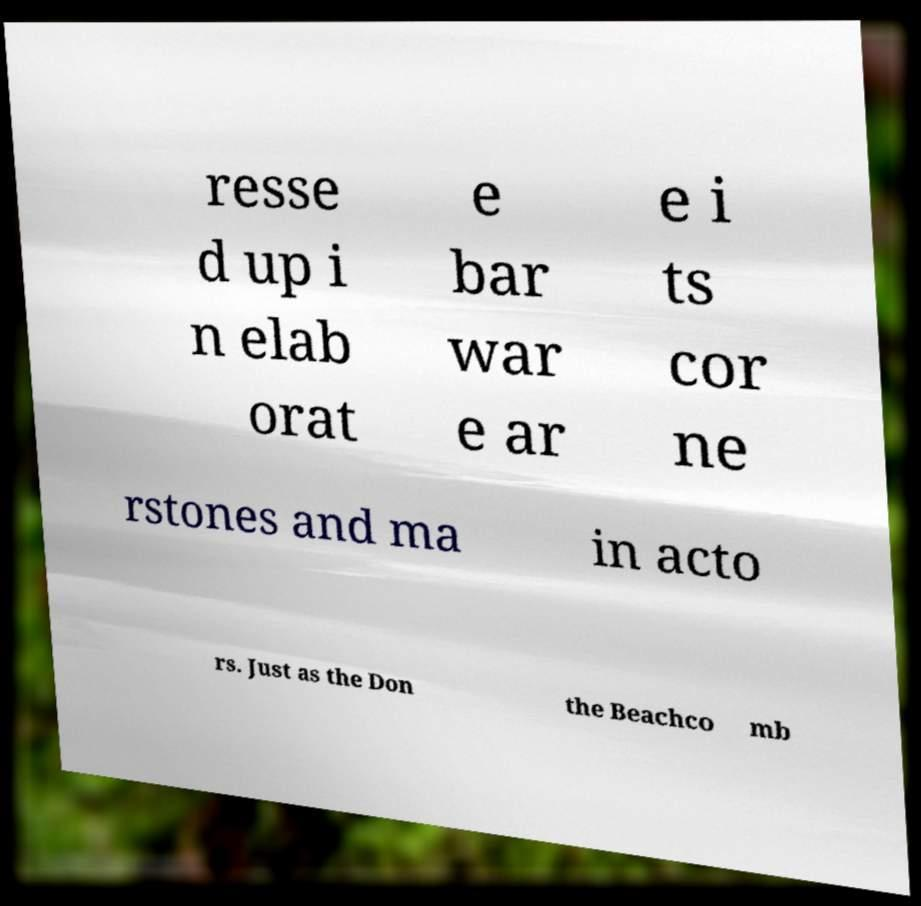For documentation purposes, I need the text within this image transcribed. Could you provide that? resse d up i n elab orat e bar war e ar e i ts cor ne rstones and ma in acto rs. Just as the Don the Beachco mb 